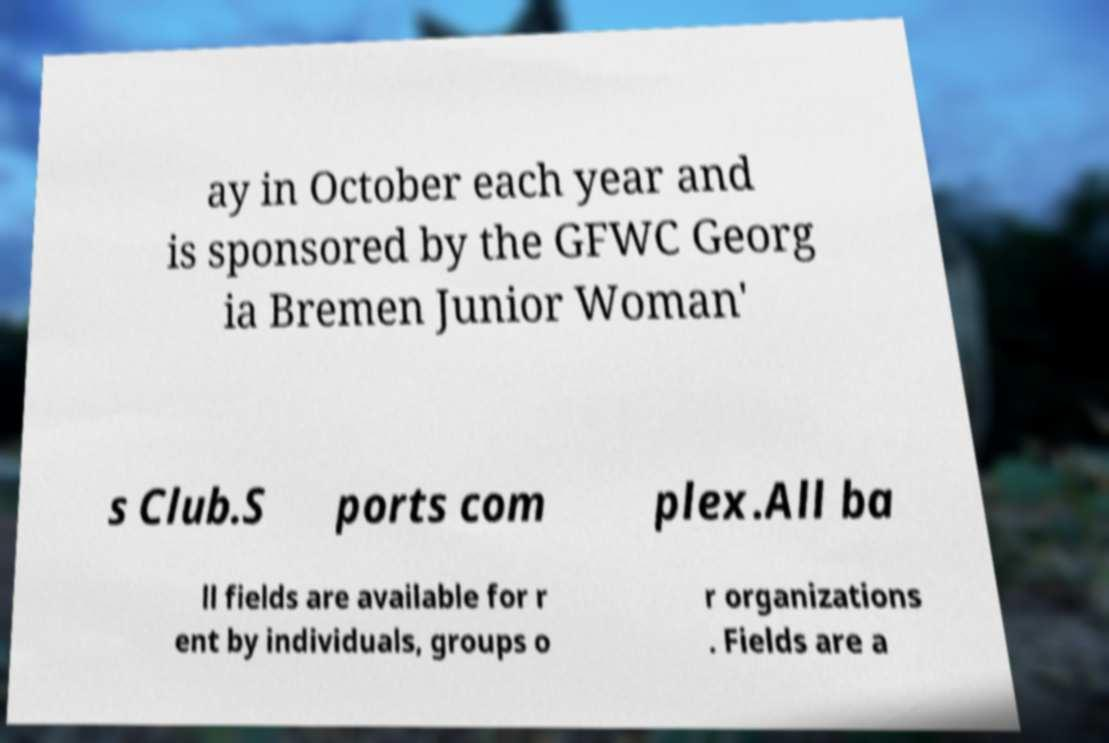Can you accurately transcribe the text from the provided image for me? ay in October each year and is sponsored by the GFWC Georg ia Bremen Junior Woman' s Club.S ports com plex.All ba ll fields are available for r ent by individuals, groups o r organizations . Fields are a 